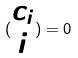Convert formula to latex. <formula><loc_0><loc_0><loc_500><loc_500>( \begin{matrix} c _ { i } \\ i \end{matrix} ) = 0</formula> 